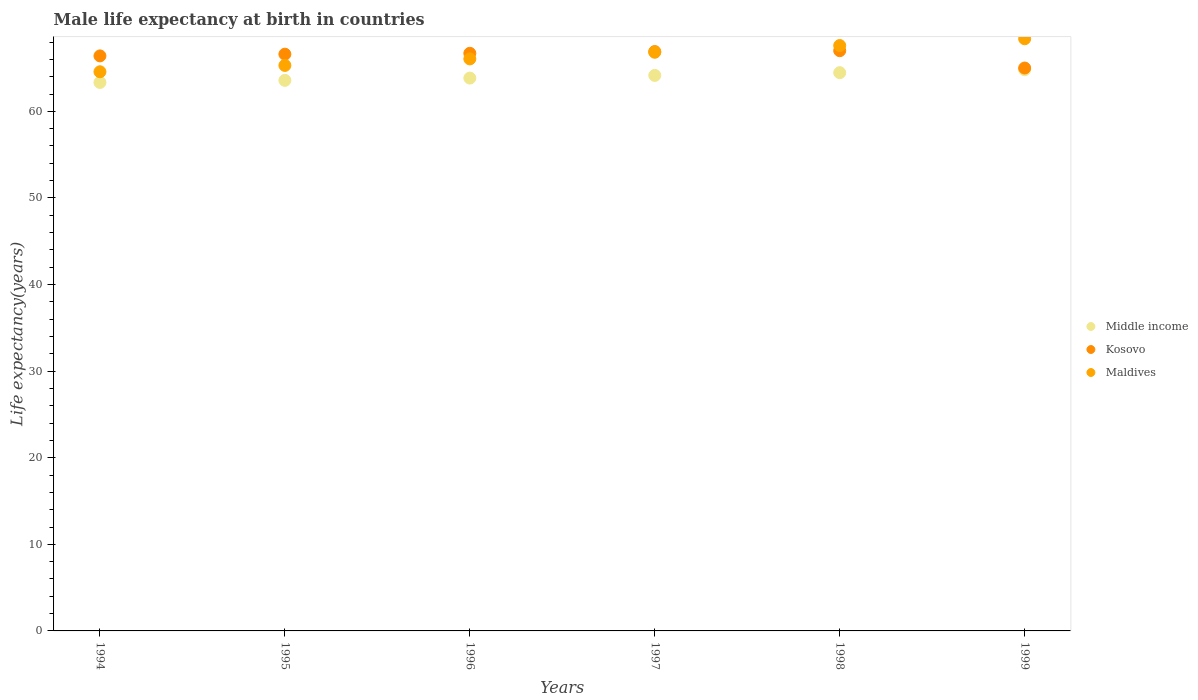How many different coloured dotlines are there?
Ensure brevity in your answer.  3. What is the male life expectancy at birth in Kosovo in 1994?
Give a very brief answer. 66.4. Across all years, what is the maximum male life expectancy at birth in Kosovo?
Provide a short and direct response. 67. In which year was the male life expectancy at birth in Middle income minimum?
Provide a short and direct response. 1994. What is the total male life expectancy at birth in Kosovo in the graph?
Make the answer very short. 398.6. What is the difference between the male life expectancy at birth in Maldives in 1996 and that in 1999?
Make the answer very short. -2.33. What is the difference between the male life expectancy at birth in Maldives in 1995 and the male life expectancy at birth in Kosovo in 1996?
Your answer should be compact. -1.4. What is the average male life expectancy at birth in Kosovo per year?
Offer a very short reply. 66.43. In the year 1999, what is the difference between the male life expectancy at birth in Kosovo and male life expectancy at birth in Middle income?
Provide a short and direct response. 0.2. In how many years, is the male life expectancy at birth in Maldives greater than 56 years?
Your response must be concise. 6. What is the ratio of the male life expectancy at birth in Kosovo in 1994 to that in 1995?
Your response must be concise. 1. Is the difference between the male life expectancy at birth in Kosovo in 1995 and 1999 greater than the difference between the male life expectancy at birth in Middle income in 1995 and 1999?
Keep it short and to the point. Yes. What is the difference between the highest and the second highest male life expectancy at birth in Kosovo?
Provide a short and direct response. 0.1. What is the difference between the highest and the lowest male life expectancy at birth in Maldives?
Your answer should be very brief. 3.81. In how many years, is the male life expectancy at birth in Middle income greater than the average male life expectancy at birth in Middle income taken over all years?
Ensure brevity in your answer.  3. Is the sum of the male life expectancy at birth in Middle income in 1994 and 1999 greater than the maximum male life expectancy at birth in Maldives across all years?
Make the answer very short. Yes. Is it the case that in every year, the sum of the male life expectancy at birth in Maldives and male life expectancy at birth in Middle income  is greater than the male life expectancy at birth in Kosovo?
Give a very brief answer. Yes. Is the male life expectancy at birth in Maldives strictly greater than the male life expectancy at birth in Kosovo over the years?
Offer a very short reply. No. Is the male life expectancy at birth in Middle income strictly less than the male life expectancy at birth in Maldives over the years?
Offer a very short reply. Yes. How many dotlines are there?
Make the answer very short. 3. How many years are there in the graph?
Offer a very short reply. 6. What is the difference between two consecutive major ticks on the Y-axis?
Your response must be concise. 10. Are the values on the major ticks of Y-axis written in scientific E-notation?
Give a very brief answer. No. Where does the legend appear in the graph?
Make the answer very short. Center right. How are the legend labels stacked?
Your answer should be compact. Vertical. What is the title of the graph?
Give a very brief answer. Male life expectancy at birth in countries. Does "New Caledonia" appear as one of the legend labels in the graph?
Ensure brevity in your answer.  No. What is the label or title of the Y-axis?
Keep it short and to the point. Life expectancy(years). What is the Life expectancy(years) in Middle income in 1994?
Offer a terse response. 63.33. What is the Life expectancy(years) in Kosovo in 1994?
Your answer should be very brief. 66.4. What is the Life expectancy(years) of Maldives in 1994?
Your answer should be very brief. 64.57. What is the Life expectancy(years) of Middle income in 1995?
Offer a terse response. 63.58. What is the Life expectancy(years) of Kosovo in 1995?
Ensure brevity in your answer.  66.6. What is the Life expectancy(years) of Maldives in 1995?
Your answer should be compact. 65.3. What is the Life expectancy(years) of Middle income in 1996?
Your response must be concise. 63.84. What is the Life expectancy(years) in Kosovo in 1996?
Your answer should be compact. 66.7. What is the Life expectancy(years) of Maldives in 1996?
Offer a very short reply. 66.05. What is the Life expectancy(years) of Middle income in 1997?
Make the answer very short. 64.15. What is the Life expectancy(years) of Kosovo in 1997?
Ensure brevity in your answer.  66.9. What is the Life expectancy(years) in Maldives in 1997?
Give a very brief answer. 66.82. What is the Life expectancy(years) of Middle income in 1998?
Your answer should be very brief. 64.46. What is the Life expectancy(years) in Kosovo in 1998?
Ensure brevity in your answer.  67. What is the Life expectancy(years) in Maldives in 1998?
Provide a succinct answer. 67.6. What is the Life expectancy(years) of Middle income in 1999?
Your answer should be very brief. 64.8. What is the Life expectancy(years) of Maldives in 1999?
Provide a succinct answer. 68.38. Across all years, what is the maximum Life expectancy(years) of Middle income?
Make the answer very short. 64.8. Across all years, what is the maximum Life expectancy(years) of Kosovo?
Your answer should be very brief. 67. Across all years, what is the maximum Life expectancy(years) in Maldives?
Ensure brevity in your answer.  68.38. Across all years, what is the minimum Life expectancy(years) in Middle income?
Offer a very short reply. 63.33. Across all years, what is the minimum Life expectancy(years) in Maldives?
Your response must be concise. 64.57. What is the total Life expectancy(years) of Middle income in the graph?
Make the answer very short. 384.16. What is the total Life expectancy(years) in Kosovo in the graph?
Your response must be concise. 398.6. What is the total Life expectancy(years) of Maldives in the graph?
Your answer should be compact. 398.72. What is the difference between the Life expectancy(years) of Middle income in 1994 and that in 1995?
Offer a very short reply. -0.24. What is the difference between the Life expectancy(years) in Kosovo in 1994 and that in 1995?
Your answer should be compact. -0.2. What is the difference between the Life expectancy(years) in Maldives in 1994 and that in 1995?
Your answer should be very brief. -0.73. What is the difference between the Life expectancy(years) of Middle income in 1994 and that in 1996?
Your response must be concise. -0.5. What is the difference between the Life expectancy(years) in Kosovo in 1994 and that in 1996?
Your response must be concise. -0.3. What is the difference between the Life expectancy(years) in Maldives in 1994 and that in 1996?
Keep it short and to the point. -1.48. What is the difference between the Life expectancy(years) of Middle income in 1994 and that in 1997?
Your answer should be compact. -0.81. What is the difference between the Life expectancy(years) of Maldives in 1994 and that in 1997?
Keep it short and to the point. -2.25. What is the difference between the Life expectancy(years) of Middle income in 1994 and that in 1998?
Give a very brief answer. -1.13. What is the difference between the Life expectancy(years) of Maldives in 1994 and that in 1998?
Offer a very short reply. -3.03. What is the difference between the Life expectancy(years) in Middle income in 1994 and that in 1999?
Your answer should be compact. -1.46. What is the difference between the Life expectancy(years) of Maldives in 1994 and that in 1999?
Your answer should be compact. -3.81. What is the difference between the Life expectancy(years) in Middle income in 1995 and that in 1996?
Offer a very short reply. -0.26. What is the difference between the Life expectancy(years) in Kosovo in 1995 and that in 1996?
Your answer should be compact. -0.1. What is the difference between the Life expectancy(years) in Maldives in 1995 and that in 1996?
Provide a succinct answer. -0.75. What is the difference between the Life expectancy(years) in Middle income in 1995 and that in 1997?
Your answer should be very brief. -0.57. What is the difference between the Life expectancy(years) in Maldives in 1995 and that in 1997?
Give a very brief answer. -1.52. What is the difference between the Life expectancy(years) in Middle income in 1995 and that in 1998?
Offer a very short reply. -0.89. What is the difference between the Life expectancy(years) of Maldives in 1995 and that in 1998?
Offer a terse response. -2.3. What is the difference between the Life expectancy(years) of Middle income in 1995 and that in 1999?
Provide a short and direct response. -1.22. What is the difference between the Life expectancy(years) of Kosovo in 1995 and that in 1999?
Your answer should be very brief. 1.6. What is the difference between the Life expectancy(years) of Maldives in 1995 and that in 1999?
Provide a succinct answer. -3.08. What is the difference between the Life expectancy(years) of Middle income in 1996 and that in 1997?
Your response must be concise. -0.31. What is the difference between the Life expectancy(years) of Maldives in 1996 and that in 1997?
Give a very brief answer. -0.77. What is the difference between the Life expectancy(years) of Middle income in 1996 and that in 1998?
Provide a short and direct response. -0.62. What is the difference between the Life expectancy(years) in Kosovo in 1996 and that in 1998?
Your answer should be compact. -0.3. What is the difference between the Life expectancy(years) of Maldives in 1996 and that in 1998?
Provide a short and direct response. -1.54. What is the difference between the Life expectancy(years) in Middle income in 1996 and that in 1999?
Give a very brief answer. -0.96. What is the difference between the Life expectancy(years) of Kosovo in 1996 and that in 1999?
Your response must be concise. 1.7. What is the difference between the Life expectancy(years) in Maldives in 1996 and that in 1999?
Keep it short and to the point. -2.33. What is the difference between the Life expectancy(years) in Middle income in 1997 and that in 1998?
Give a very brief answer. -0.32. What is the difference between the Life expectancy(years) of Maldives in 1997 and that in 1998?
Make the answer very short. -0.78. What is the difference between the Life expectancy(years) in Middle income in 1997 and that in 1999?
Your response must be concise. -0.65. What is the difference between the Life expectancy(years) in Kosovo in 1997 and that in 1999?
Provide a short and direct response. 1.9. What is the difference between the Life expectancy(years) in Maldives in 1997 and that in 1999?
Your answer should be very brief. -1.56. What is the difference between the Life expectancy(years) in Middle income in 1998 and that in 1999?
Provide a succinct answer. -0.34. What is the difference between the Life expectancy(years) of Kosovo in 1998 and that in 1999?
Keep it short and to the point. 2. What is the difference between the Life expectancy(years) in Maldives in 1998 and that in 1999?
Give a very brief answer. -0.78. What is the difference between the Life expectancy(years) of Middle income in 1994 and the Life expectancy(years) of Kosovo in 1995?
Provide a short and direct response. -3.27. What is the difference between the Life expectancy(years) of Middle income in 1994 and the Life expectancy(years) of Maldives in 1995?
Your answer should be compact. -1.97. What is the difference between the Life expectancy(years) of Kosovo in 1994 and the Life expectancy(years) of Maldives in 1995?
Your response must be concise. 1.1. What is the difference between the Life expectancy(years) of Middle income in 1994 and the Life expectancy(years) of Kosovo in 1996?
Give a very brief answer. -3.37. What is the difference between the Life expectancy(years) of Middle income in 1994 and the Life expectancy(years) of Maldives in 1996?
Your response must be concise. -2.72. What is the difference between the Life expectancy(years) of Kosovo in 1994 and the Life expectancy(years) of Maldives in 1996?
Your answer should be very brief. 0.35. What is the difference between the Life expectancy(years) of Middle income in 1994 and the Life expectancy(years) of Kosovo in 1997?
Your answer should be very brief. -3.56. What is the difference between the Life expectancy(years) in Middle income in 1994 and the Life expectancy(years) in Maldives in 1997?
Ensure brevity in your answer.  -3.48. What is the difference between the Life expectancy(years) in Kosovo in 1994 and the Life expectancy(years) in Maldives in 1997?
Offer a very short reply. -0.42. What is the difference between the Life expectancy(years) of Middle income in 1994 and the Life expectancy(years) of Kosovo in 1998?
Keep it short and to the point. -3.67. What is the difference between the Life expectancy(years) of Middle income in 1994 and the Life expectancy(years) of Maldives in 1998?
Offer a terse response. -4.26. What is the difference between the Life expectancy(years) in Kosovo in 1994 and the Life expectancy(years) in Maldives in 1998?
Offer a terse response. -1.2. What is the difference between the Life expectancy(years) of Middle income in 1994 and the Life expectancy(years) of Kosovo in 1999?
Provide a succinct answer. -1.67. What is the difference between the Life expectancy(years) of Middle income in 1994 and the Life expectancy(years) of Maldives in 1999?
Give a very brief answer. -5.04. What is the difference between the Life expectancy(years) in Kosovo in 1994 and the Life expectancy(years) in Maldives in 1999?
Your response must be concise. -1.98. What is the difference between the Life expectancy(years) of Middle income in 1995 and the Life expectancy(years) of Kosovo in 1996?
Your answer should be compact. -3.12. What is the difference between the Life expectancy(years) in Middle income in 1995 and the Life expectancy(years) in Maldives in 1996?
Ensure brevity in your answer.  -2.48. What is the difference between the Life expectancy(years) of Kosovo in 1995 and the Life expectancy(years) of Maldives in 1996?
Offer a very short reply. 0.55. What is the difference between the Life expectancy(years) of Middle income in 1995 and the Life expectancy(years) of Kosovo in 1997?
Provide a succinct answer. -3.32. What is the difference between the Life expectancy(years) of Middle income in 1995 and the Life expectancy(years) of Maldives in 1997?
Your answer should be very brief. -3.24. What is the difference between the Life expectancy(years) of Kosovo in 1995 and the Life expectancy(years) of Maldives in 1997?
Offer a very short reply. -0.22. What is the difference between the Life expectancy(years) of Middle income in 1995 and the Life expectancy(years) of Kosovo in 1998?
Your response must be concise. -3.42. What is the difference between the Life expectancy(years) of Middle income in 1995 and the Life expectancy(years) of Maldives in 1998?
Your response must be concise. -4.02. What is the difference between the Life expectancy(years) in Kosovo in 1995 and the Life expectancy(years) in Maldives in 1998?
Provide a short and direct response. -1. What is the difference between the Life expectancy(years) in Middle income in 1995 and the Life expectancy(years) in Kosovo in 1999?
Make the answer very short. -1.42. What is the difference between the Life expectancy(years) of Middle income in 1995 and the Life expectancy(years) of Maldives in 1999?
Provide a short and direct response. -4.8. What is the difference between the Life expectancy(years) in Kosovo in 1995 and the Life expectancy(years) in Maldives in 1999?
Your answer should be very brief. -1.78. What is the difference between the Life expectancy(years) in Middle income in 1996 and the Life expectancy(years) in Kosovo in 1997?
Your answer should be compact. -3.06. What is the difference between the Life expectancy(years) of Middle income in 1996 and the Life expectancy(years) of Maldives in 1997?
Offer a terse response. -2.98. What is the difference between the Life expectancy(years) in Kosovo in 1996 and the Life expectancy(years) in Maldives in 1997?
Provide a succinct answer. -0.12. What is the difference between the Life expectancy(years) in Middle income in 1996 and the Life expectancy(years) in Kosovo in 1998?
Your answer should be compact. -3.16. What is the difference between the Life expectancy(years) in Middle income in 1996 and the Life expectancy(years) in Maldives in 1998?
Your answer should be compact. -3.76. What is the difference between the Life expectancy(years) of Kosovo in 1996 and the Life expectancy(years) of Maldives in 1998?
Your response must be concise. -0.9. What is the difference between the Life expectancy(years) of Middle income in 1996 and the Life expectancy(years) of Kosovo in 1999?
Make the answer very short. -1.16. What is the difference between the Life expectancy(years) in Middle income in 1996 and the Life expectancy(years) in Maldives in 1999?
Offer a very short reply. -4.54. What is the difference between the Life expectancy(years) of Kosovo in 1996 and the Life expectancy(years) of Maldives in 1999?
Your response must be concise. -1.68. What is the difference between the Life expectancy(years) of Middle income in 1997 and the Life expectancy(years) of Kosovo in 1998?
Your response must be concise. -2.85. What is the difference between the Life expectancy(years) of Middle income in 1997 and the Life expectancy(years) of Maldives in 1998?
Ensure brevity in your answer.  -3.45. What is the difference between the Life expectancy(years) of Kosovo in 1997 and the Life expectancy(years) of Maldives in 1998?
Your response must be concise. -0.7. What is the difference between the Life expectancy(years) of Middle income in 1997 and the Life expectancy(years) of Kosovo in 1999?
Provide a short and direct response. -0.85. What is the difference between the Life expectancy(years) of Middle income in 1997 and the Life expectancy(years) of Maldives in 1999?
Provide a succinct answer. -4.23. What is the difference between the Life expectancy(years) in Kosovo in 1997 and the Life expectancy(years) in Maldives in 1999?
Your response must be concise. -1.48. What is the difference between the Life expectancy(years) of Middle income in 1998 and the Life expectancy(years) of Kosovo in 1999?
Make the answer very short. -0.54. What is the difference between the Life expectancy(years) of Middle income in 1998 and the Life expectancy(years) of Maldives in 1999?
Provide a succinct answer. -3.92. What is the difference between the Life expectancy(years) in Kosovo in 1998 and the Life expectancy(years) in Maldives in 1999?
Your response must be concise. -1.38. What is the average Life expectancy(years) of Middle income per year?
Provide a succinct answer. 64.03. What is the average Life expectancy(years) in Kosovo per year?
Ensure brevity in your answer.  66.43. What is the average Life expectancy(years) in Maldives per year?
Your answer should be compact. 66.45. In the year 1994, what is the difference between the Life expectancy(years) of Middle income and Life expectancy(years) of Kosovo?
Your answer should be compact. -3.06. In the year 1994, what is the difference between the Life expectancy(years) of Middle income and Life expectancy(years) of Maldives?
Keep it short and to the point. -1.23. In the year 1994, what is the difference between the Life expectancy(years) of Kosovo and Life expectancy(years) of Maldives?
Make the answer very short. 1.83. In the year 1995, what is the difference between the Life expectancy(years) of Middle income and Life expectancy(years) of Kosovo?
Your answer should be very brief. -3.02. In the year 1995, what is the difference between the Life expectancy(years) in Middle income and Life expectancy(years) in Maldives?
Your response must be concise. -1.72. In the year 1995, what is the difference between the Life expectancy(years) in Kosovo and Life expectancy(years) in Maldives?
Your answer should be very brief. 1.3. In the year 1996, what is the difference between the Life expectancy(years) of Middle income and Life expectancy(years) of Kosovo?
Provide a succinct answer. -2.86. In the year 1996, what is the difference between the Life expectancy(years) in Middle income and Life expectancy(years) in Maldives?
Offer a terse response. -2.21. In the year 1996, what is the difference between the Life expectancy(years) in Kosovo and Life expectancy(years) in Maldives?
Give a very brief answer. 0.65. In the year 1997, what is the difference between the Life expectancy(years) in Middle income and Life expectancy(years) in Kosovo?
Ensure brevity in your answer.  -2.75. In the year 1997, what is the difference between the Life expectancy(years) of Middle income and Life expectancy(years) of Maldives?
Your response must be concise. -2.67. In the year 1998, what is the difference between the Life expectancy(years) in Middle income and Life expectancy(years) in Kosovo?
Make the answer very short. -2.54. In the year 1998, what is the difference between the Life expectancy(years) in Middle income and Life expectancy(years) in Maldives?
Your answer should be compact. -3.14. In the year 1998, what is the difference between the Life expectancy(years) in Kosovo and Life expectancy(years) in Maldives?
Ensure brevity in your answer.  -0.6. In the year 1999, what is the difference between the Life expectancy(years) of Middle income and Life expectancy(years) of Kosovo?
Offer a terse response. -0.2. In the year 1999, what is the difference between the Life expectancy(years) in Middle income and Life expectancy(years) in Maldives?
Ensure brevity in your answer.  -3.58. In the year 1999, what is the difference between the Life expectancy(years) in Kosovo and Life expectancy(years) in Maldives?
Keep it short and to the point. -3.38. What is the ratio of the Life expectancy(years) in Middle income in 1994 to that in 1995?
Ensure brevity in your answer.  1. What is the ratio of the Life expectancy(years) in Middle income in 1994 to that in 1996?
Ensure brevity in your answer.  0.99. What is the ratio of the Life expectancy(years) in Maldives in 1994 to that in 1996?
Give a very brief answer. 0.98. What is the ratio of the Life expectancy(years) in Middle income in 1994 to that in 1997?
Provide a succinct answer. 0.99. What is the ratio of the Life expectancy(years) in Kosovo in 1994 to that in 1997?
Your response must be concise. 0.99. What is the ratio of the Life expectancy(years) of Maldives in 1994 to that in 1997?
Ensure brevity in your answer.  0.97. What is the ratio of the Life expectancy(years) of Middle income in 1994 to that in 1998?
Give a very brief answer. 0.98. What is the ratio of the Life expectancy(years) of Kosovo in 1994 to that in 1998?
Your answer should be compact. 0.99. What is the ratio of the Life expectancy(years) in Maldives in 1994 to that in 1998?
Offer a terse response. 0.96. What is the ratio of the Life expectancy(years) of Middle income in 1994 to that in 1999?
Keep it short and to the point. 0.98. What is the ratio of the Life expectancy(years) in Kosovo in 1994 to that in 1999?
Provide a short and direct response. 1.02. What is the ratio of the Life expectancy(years) of Maldives in 1994 to that in 1999?
Offer a very short reply. 0.94. What is the ratio of the Life expectancy(years) in Middle income in 1995 to that in 1996?
Your answer should be compact. 1. What is the ratio of the Life expectancy(years) in Kosovo in 1995 to that in 1996?
Provide a short and direct response. 1. What is the ratio of the Life expectancy(years) of Maldives in 1995 to that in 1996?
Your answer should be very brief. 0.99. What is the ratio of the Life expectancy(years) in Maldives in 1995 to that in 1997?
Provide a short and direct response. 0.98. What is the ratio of the Life expectancy(years) in Middle income in 1995 to that in 1998?
Provide a short and direct response. 0.99. What is the ratio of the Life expectancy(years) of Maldives in 1995 to that in 1998?
Provide a succinct answer. 0.97. What is the ratio of the Life expectancy(years) in Middle income in 1995 to that in 1999?
Provide a succinct answer. 0.98. What is the ratio of the Life expectancy(years) of Kosovo in 1995 to that in 1999?
Your answer should be compact. 1.02. What is the ratio of the Life expectancy(years) in Maldives in 1995 to that in 1999?
Ensure brevity in your answer.  0.95. What is the ratio of the Life expectancy(years) of Middle income in 1996 to that in 1997?
Your answer should be compact. 1. What is the ratio of the Life expectancy(years) of Kosovo in 1996 to that in 1997?
Your response must be concise. 1. What is the ratio of the Life expectancy(years) of Maldives in 1996 to that in 1997?
Your answer should be very brief. 0.99. What is the ratio of the Life expectancy(years) in Middle income in 1996 to that in 1998?
Offer a terse response. 0.99. What is the ratio of the Life expectancy(years) of Maldives in 1996 to that in 1998?
Your answer should be compact. 0.98. What is the ratio of the Life expectancy(years) in Middle income in 1996 to that in 1999?
Offer a very short reply. 0.99. What is the ratio of the Life expectancy(years) of Kosovo in 1996 to that in 1999?
Ensure brevity in your answer.  1.03. What is the ratio of the Life expectancy(years) of Maldives in 1996 to that in 1999?
Offer a very short reply. 0.97. What is the ratio of the Life expectancy(years) of Kosovo in 1997 to that in 1998?
Provide a succinct answer. 1. What is the ratio of the Life expectancy(years) of Maldives in 1997 to that in 1998?
Ensure brevity in your answer.  0.99. What is the ratio of the Life expectancy(years) of Middle income in 1997 to that in 1999?
Offer a terse response. 0.99. What is the ratio of the Life expectancy(years) of Kosovo in 1997 to that in 1999?
Your answer should be very brief. 1.03. What is the ratio of the Life expectancy(years) in Maldives in 1997 to that in 1999?
Your answer should be compact. 0.98. What is the ratio of the Life expectancy(years) of Kosovo in 1998 to that in 1999?
Your response must be concise. 1.03. What is the difference between the highest and the second highest Life expectancy(years) of Middle income?
Your answer should be very brief. 0.34. What is the difference between the highest and the second highest Life expectancy(years) of Maldives?
Provide a short and direct response. 0.78. What is the difference between the highest and the lowest Life expectancy(years) of Middle income?
Offer a very short reply. 1.46. What is the difference between the highest and the lowest Life expectancy(years) in Maldives?
Your answer should be very brief. 3.81. 